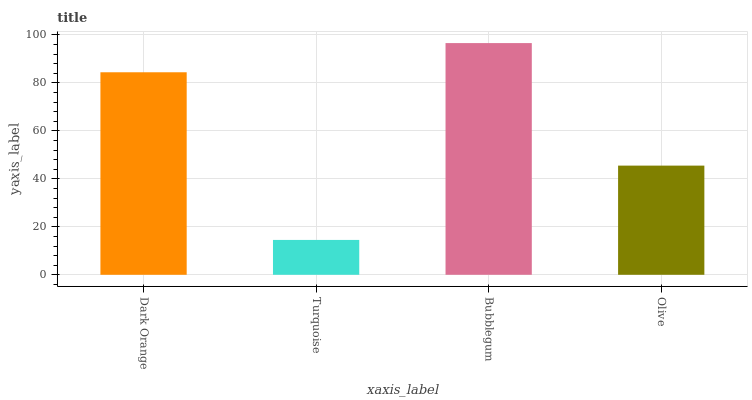Is Turquoise the minimum?
Answer yes or no. Yes. Is Bubblegum the maximum?
Answer yes or no. Yes. Is Bubblegum the minimum?
Answer yes or no. No. Is Turquoise the maximum?
Answer yes or no. No. Is Bubblegum greater than Turquoise?
Answer yes or no. Yes. Is Turquoise less than Bubblegum?
Answer yes or no. Yes. Is Turquoise greater than Bubblegum?
Answer yes or no. No. Is Bubblegum less than Turquoise?
Answer yes or no. No. Is Dark Orange the high median?
Answer yes or no. Yes. Is Olive the low median?
Answer yes or no. Yes. Is Turquoise the high median?
Answer yes or no. No. Is Bubblegum the low median?
Answer yes or no. No. 